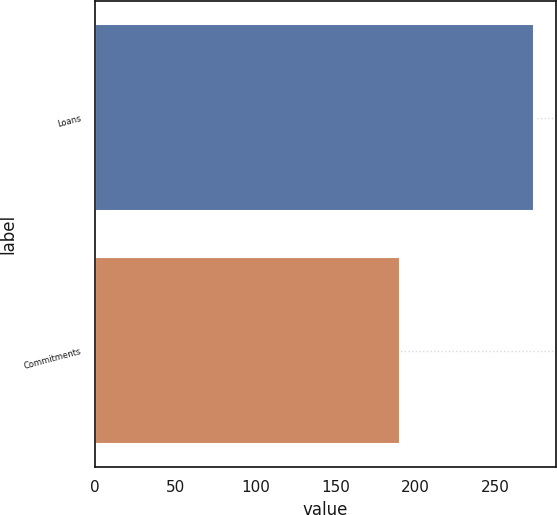Convert chart. <chart><loc_0><loc_0><loc_500><loc_500><bar_chart><fcel>Loans<fcel>Commitments<nl><fcel>274<fcel>190<nl></chart> 